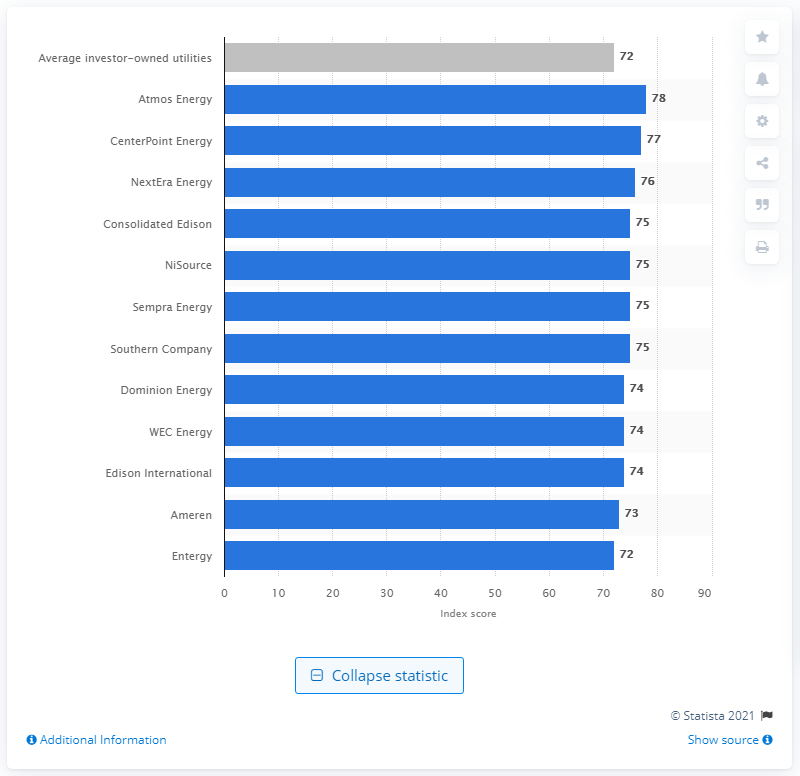Identify some key points in this picture. Atmos Energy is the American utility company with the highest customer satisfaction score. In 2020, the average index score for investor-owned utilities in the United States was 72. 